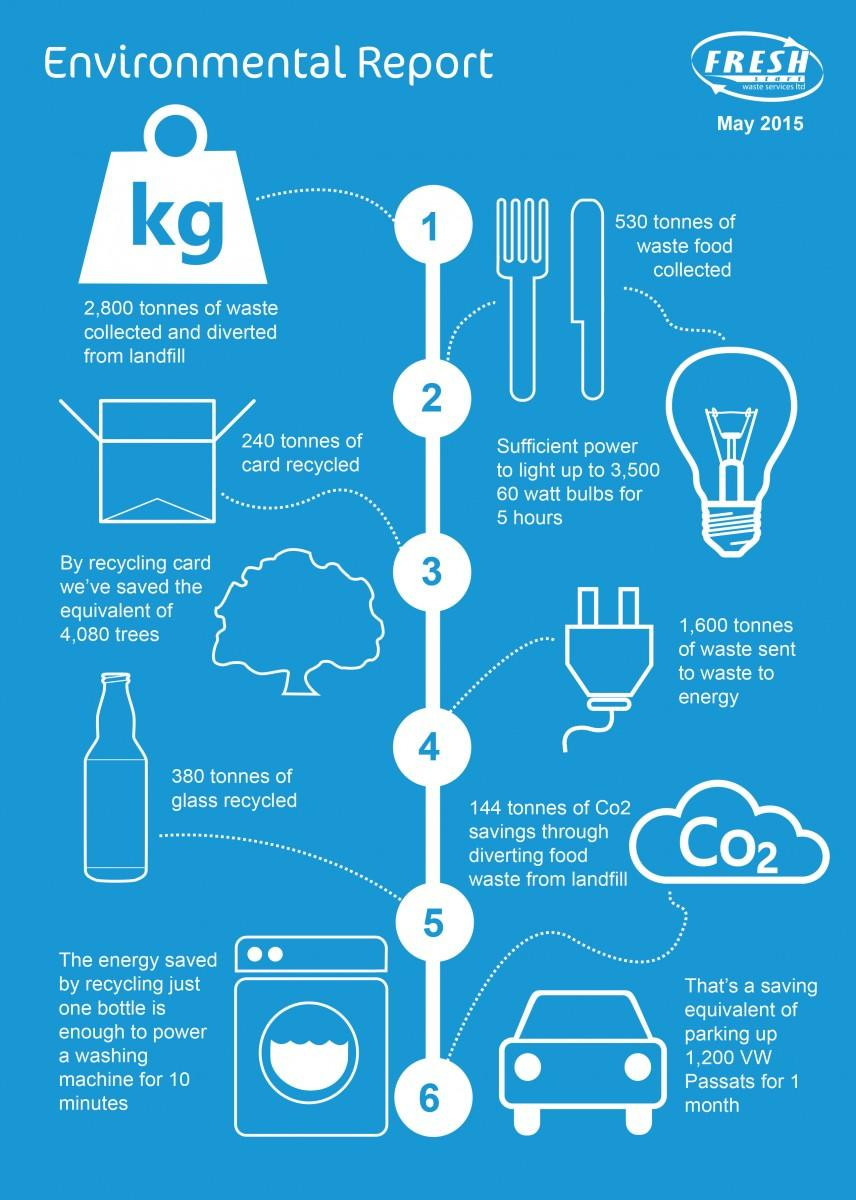Outline some significant characteristics in this image. The recycling of 240 tonnes of cardboard resulted in a saving equivalent to 4,080 trees. The collection of waste food among the total waste amounted to 530 tons out of 2,800 tons. 